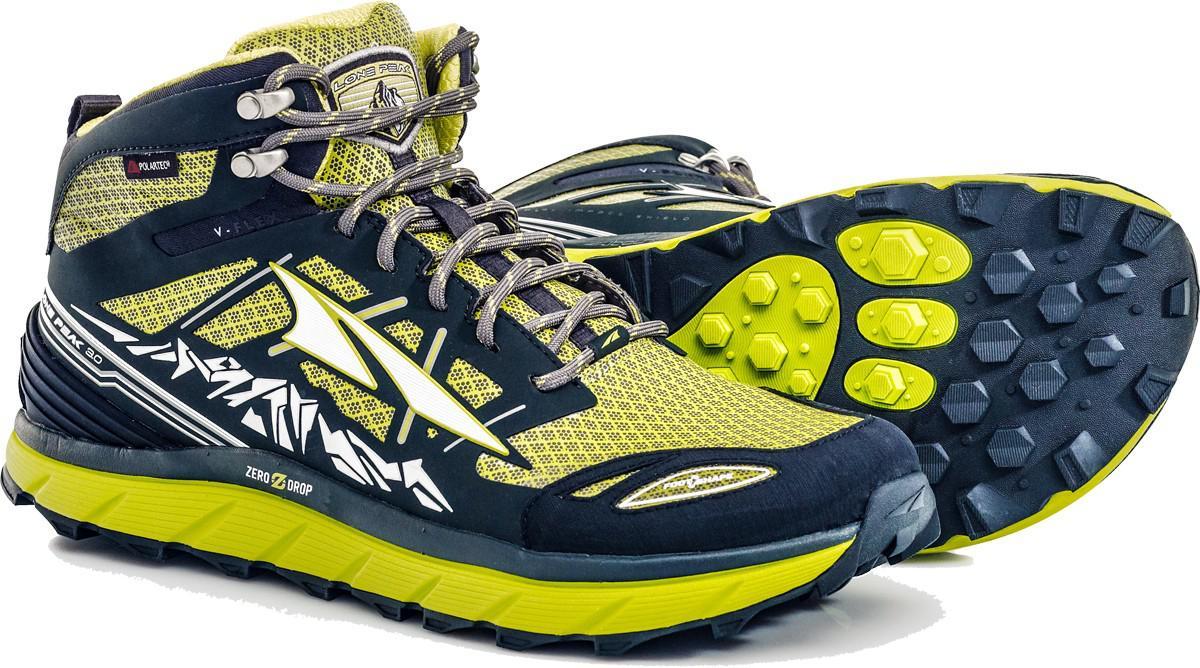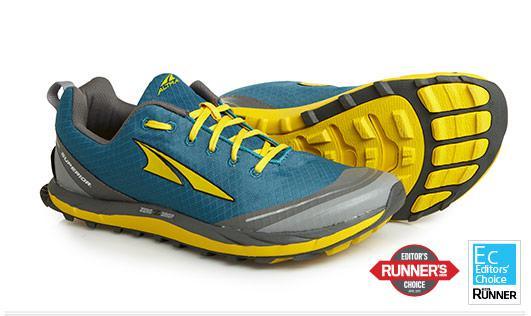The first image is the image on the left, the second image is the image on the right. For the images displayed, is the sentence "Two pairs of shoes, each laced with coordinating laces, are shown with one shoe sideways and the other shoe laying behind it with a colorful sole showing." factually correct? Answer yes or no. Yes. The first image is the image on the left, the second image is the image on the right. Assess this claim about the two images: "Each image contains only one pair of shoes, and each pair is displayed with one shoe in front of a shoe turned on its side.". Correct or not? Answer yes or no. Yes. 